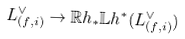<formula> <loc_0><loc_0><loc_500><loc_500>L _ { ( f , i ) } ^ { \vee } \rightarrow \mathbb { R } h _ { * } \mathbb { L } h ^ { * } ( L _ { ( f , i ) } ^ { \vee } )</formula> 